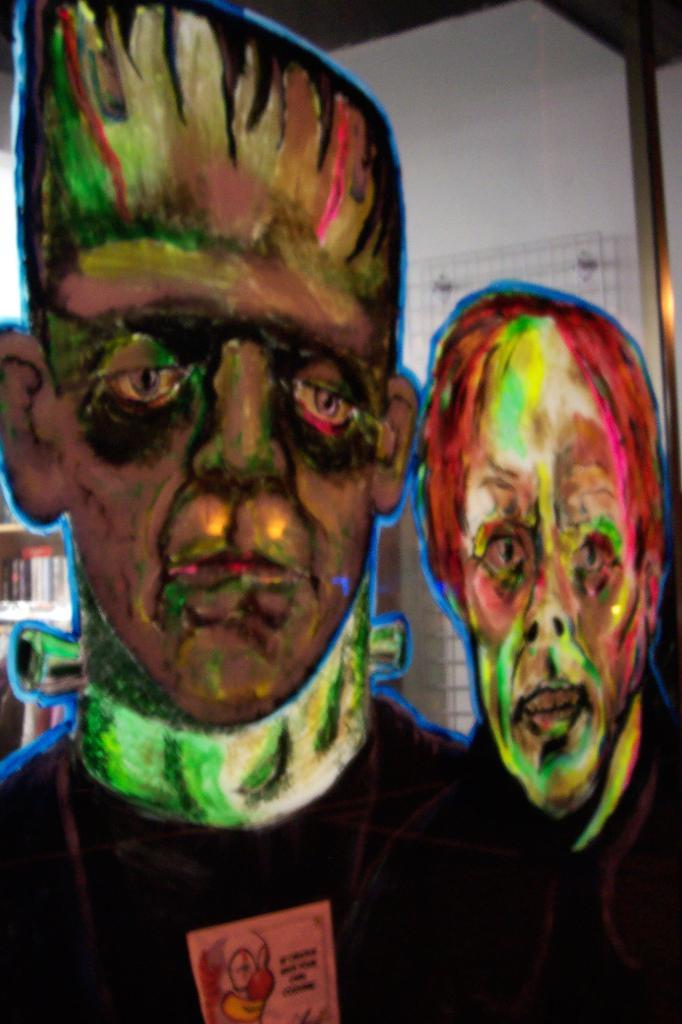What type of artwork is displayed on the wall in the image? There are paintings on the wall in the image. What can be seen in the background of the image? There is a bookshelf in the background of the image. What type of pail is used for writing in the image? There is no pail or writing present in the image. What things are being written about in the image? There is no writing present in the image, so it is not possible to determine what things might be written about. 